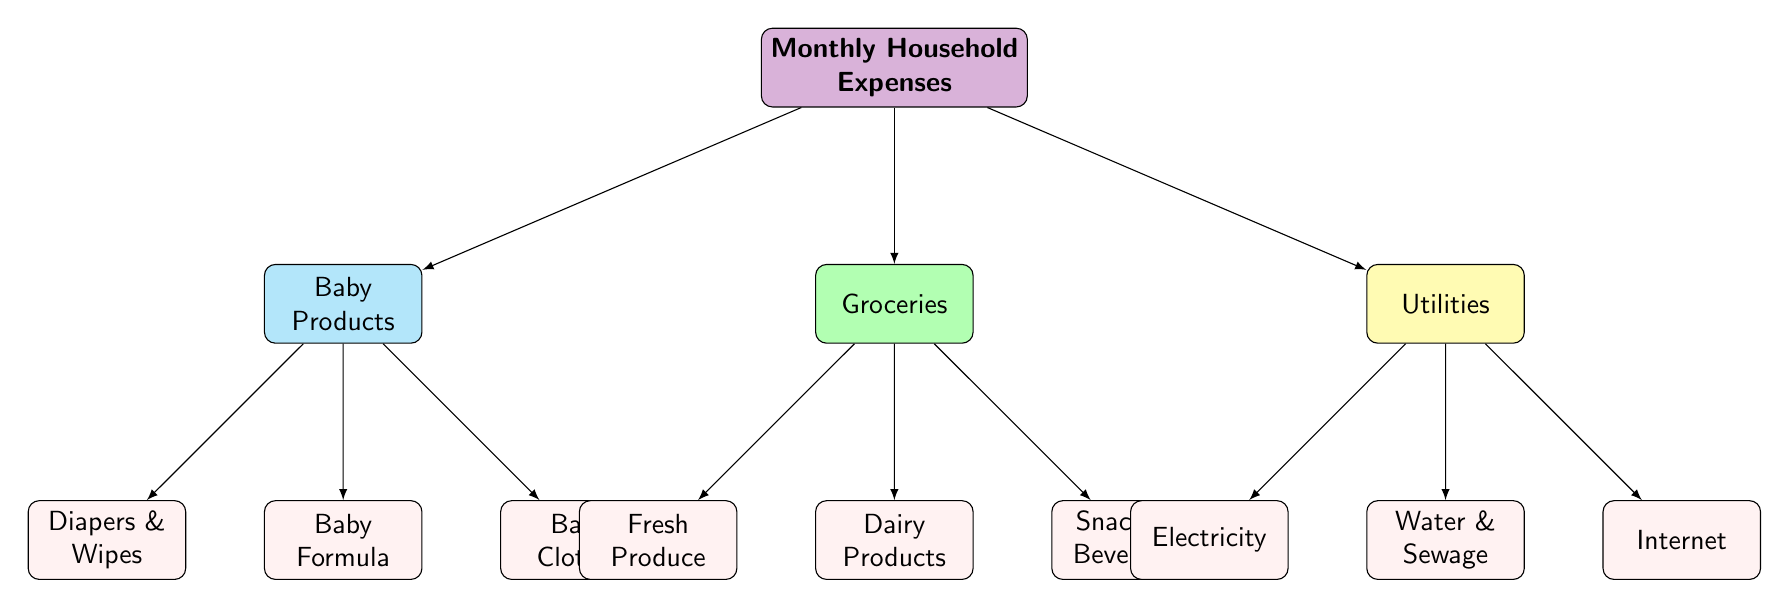What are the three main categories of monthly household expenses? The diagram shows three main categories under "Monthly Household Expenses": Baby Products, Groceries, and Utilities.
Answer: Baby Products, Groceries, Utilities How many types of baby products are listed? Under the Baby Products category, there are three types: Diapers & Wipes, Baby Formula, and Baby Clothes. This is counted as three distinct items.
Answer: 3 Which category includes Dairy Products? The Dairy Products are specifically listed under the Groceries category, which is one of the three primary categories of expenses.
Answer: Groceries What is the color representing Utilities? In the diagram, Utilities are represented with a yellow color, distinguishing it from the other categories.
Answer: Yellow Which two items are listed under Baby Products? Under the Baby Products category, the items listed are Diapers & Wipes, Baby Formula, and Baby Clothes. The two items requested here could be any two of the three, but they must be selected from this list.
Answer: Diapers & Wipes, Baby Formula (or any other combination of two) If you combine the categories Baby Products and Groceries, how many total items do you have? The Baby Products category has three items, and the Groceries category has three items, which when combined total six items altogether.
Answer: 6 What type of products fall under the category Snacks & Beverages? Snacks & Beverages are specifically listed under the Groceries category, indicating that they are consumer food items typically purchased for convenience.
Answer: Snacks & Beverages Identify a utility expense mentioned in the diagram. The diagram specifies three utility expenses: Electricity, Water & Sewage, and Internet. Any one of these can correctly answer the question.
Answer: Electricity (or any other utility expense from the list) What is the relationship between Baby Products and Groceries in the diagram? Baby Products and Groceries are both child nodes stemming from the main node "Monthly Household Expenses," indicating that they are both subcategories of household expenses.
Answer: Sibling categories 